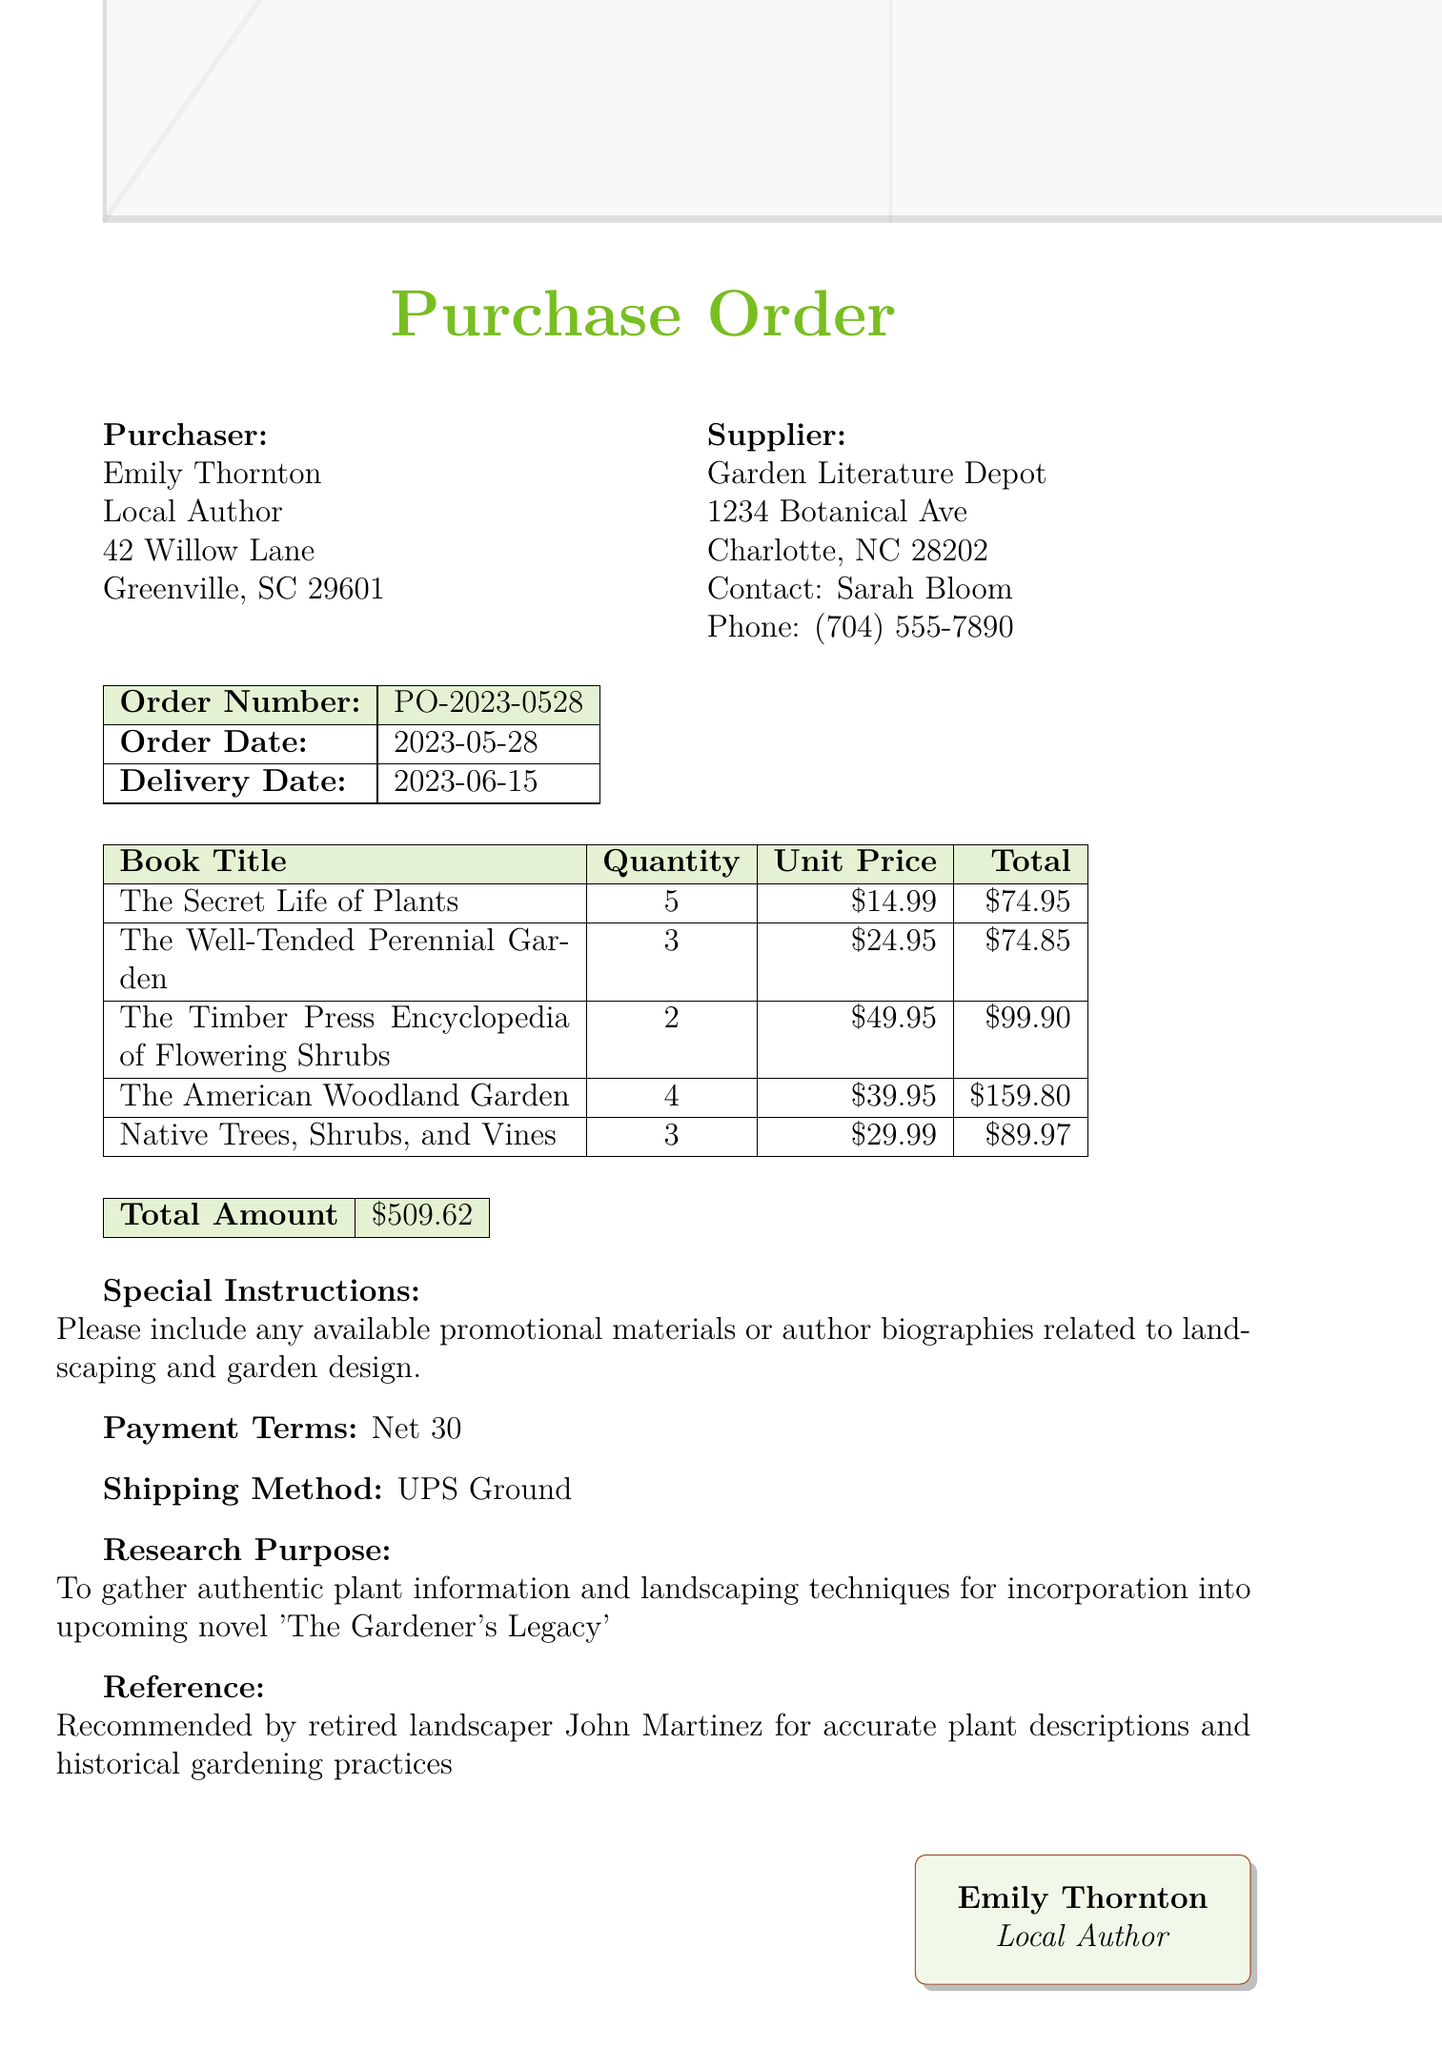what is the name of the purchaser? The name of the purchaser is mentioned at the top of the document.
Answer: Emily Thornton what is the contact person's name at the supplier? The supplier's contact person's name is listed under the supplier section.
Answer: Sarah Bloom what is the order number? The order number is specified in the order details section.
Answer: PO-2023-0528 what is the delivery date? The delivery date is stated in the order details of the document.
Answer: 2023-06-15 how many copies of "The Secret Life of Plants" were ordered? The quantity of "The Secret Life of Plants" is given in the list of books.
Answer: 5 what is the total amount for the order? The total amount is presented in the summary table at the end of the document.
Answer: $509.62 what is the shipping method specified in the document? The shipping method is included in the additional details at the end.
Answer: UPS Ground what is the research purpose mentioned in the order? The research purpose is specified toward the end of the document.
Answer: To gather authentic plant information and landscaping techniques for incorporation into upcoming novel 'The Gardener's Legacy' who recommended the supplier for accurate plant descriptions? The document provides a reference to the person who recommended the supplier.
Answer: John Martinez 